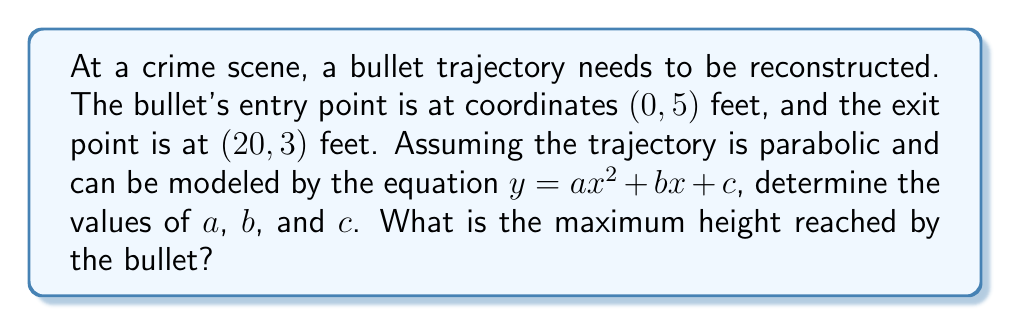Show me your answer to this math problem. 1) We know two points on the parabola: (0, 5) and (20, 3). Let's use these to set up two equations:

   $5 = a(0)^2 + b(0) + c$
   $5 = c$ (Equation 1)

   $3 = a(20)^2 + b(20) + c$
   $3 = 400a + 20b + 5$ (Equation 2)

2) Substitute Equation 1 into Equation 2:
   $3 = 400a + 20b + 5$
   $-2 = 400a + 20b$

3) We need a third equation. We can use the fact that the bullet entered at (0, 5):
   The derivative at x = 0 should be negative (bullet is descending).
   $y' = 2ax + b$
   At x = 0: $y' = b$ (should be negative)
   Let's say $b = -0.2$ (any negative value would work)

4) Now we can solve for $a$:
   $-2 = 400a + 20(-0.2)$
   $-2 = 400a - 4$
   $2 = 400a$
   $a = 0.005$

5) We now have $a = 0.005$, $b = -0.2$, and $c = 5$

6) The equation of the trajectory is:
   $y = 0.005x^2 - 0.2x + 5$

7) To find the maximum height, we find where $y' = 0$:
   $y' = 0.01x - 0.2 = 0$
   $0.01x = 0.2$
   $x = 20$

8) The maximum height occurs at $x = 20$. Plugging this back into the original equation:
   $y = 0.005(20)^2 - 0.2(20) + 5$
   $y = 2 - 4 + 5 = 3$

The maximum height is 3 feet, which occurs at the exit point.
Answer: $a = 0.005$, $b = -0.2$, $c = 5$; Maximum height: 3 feet 